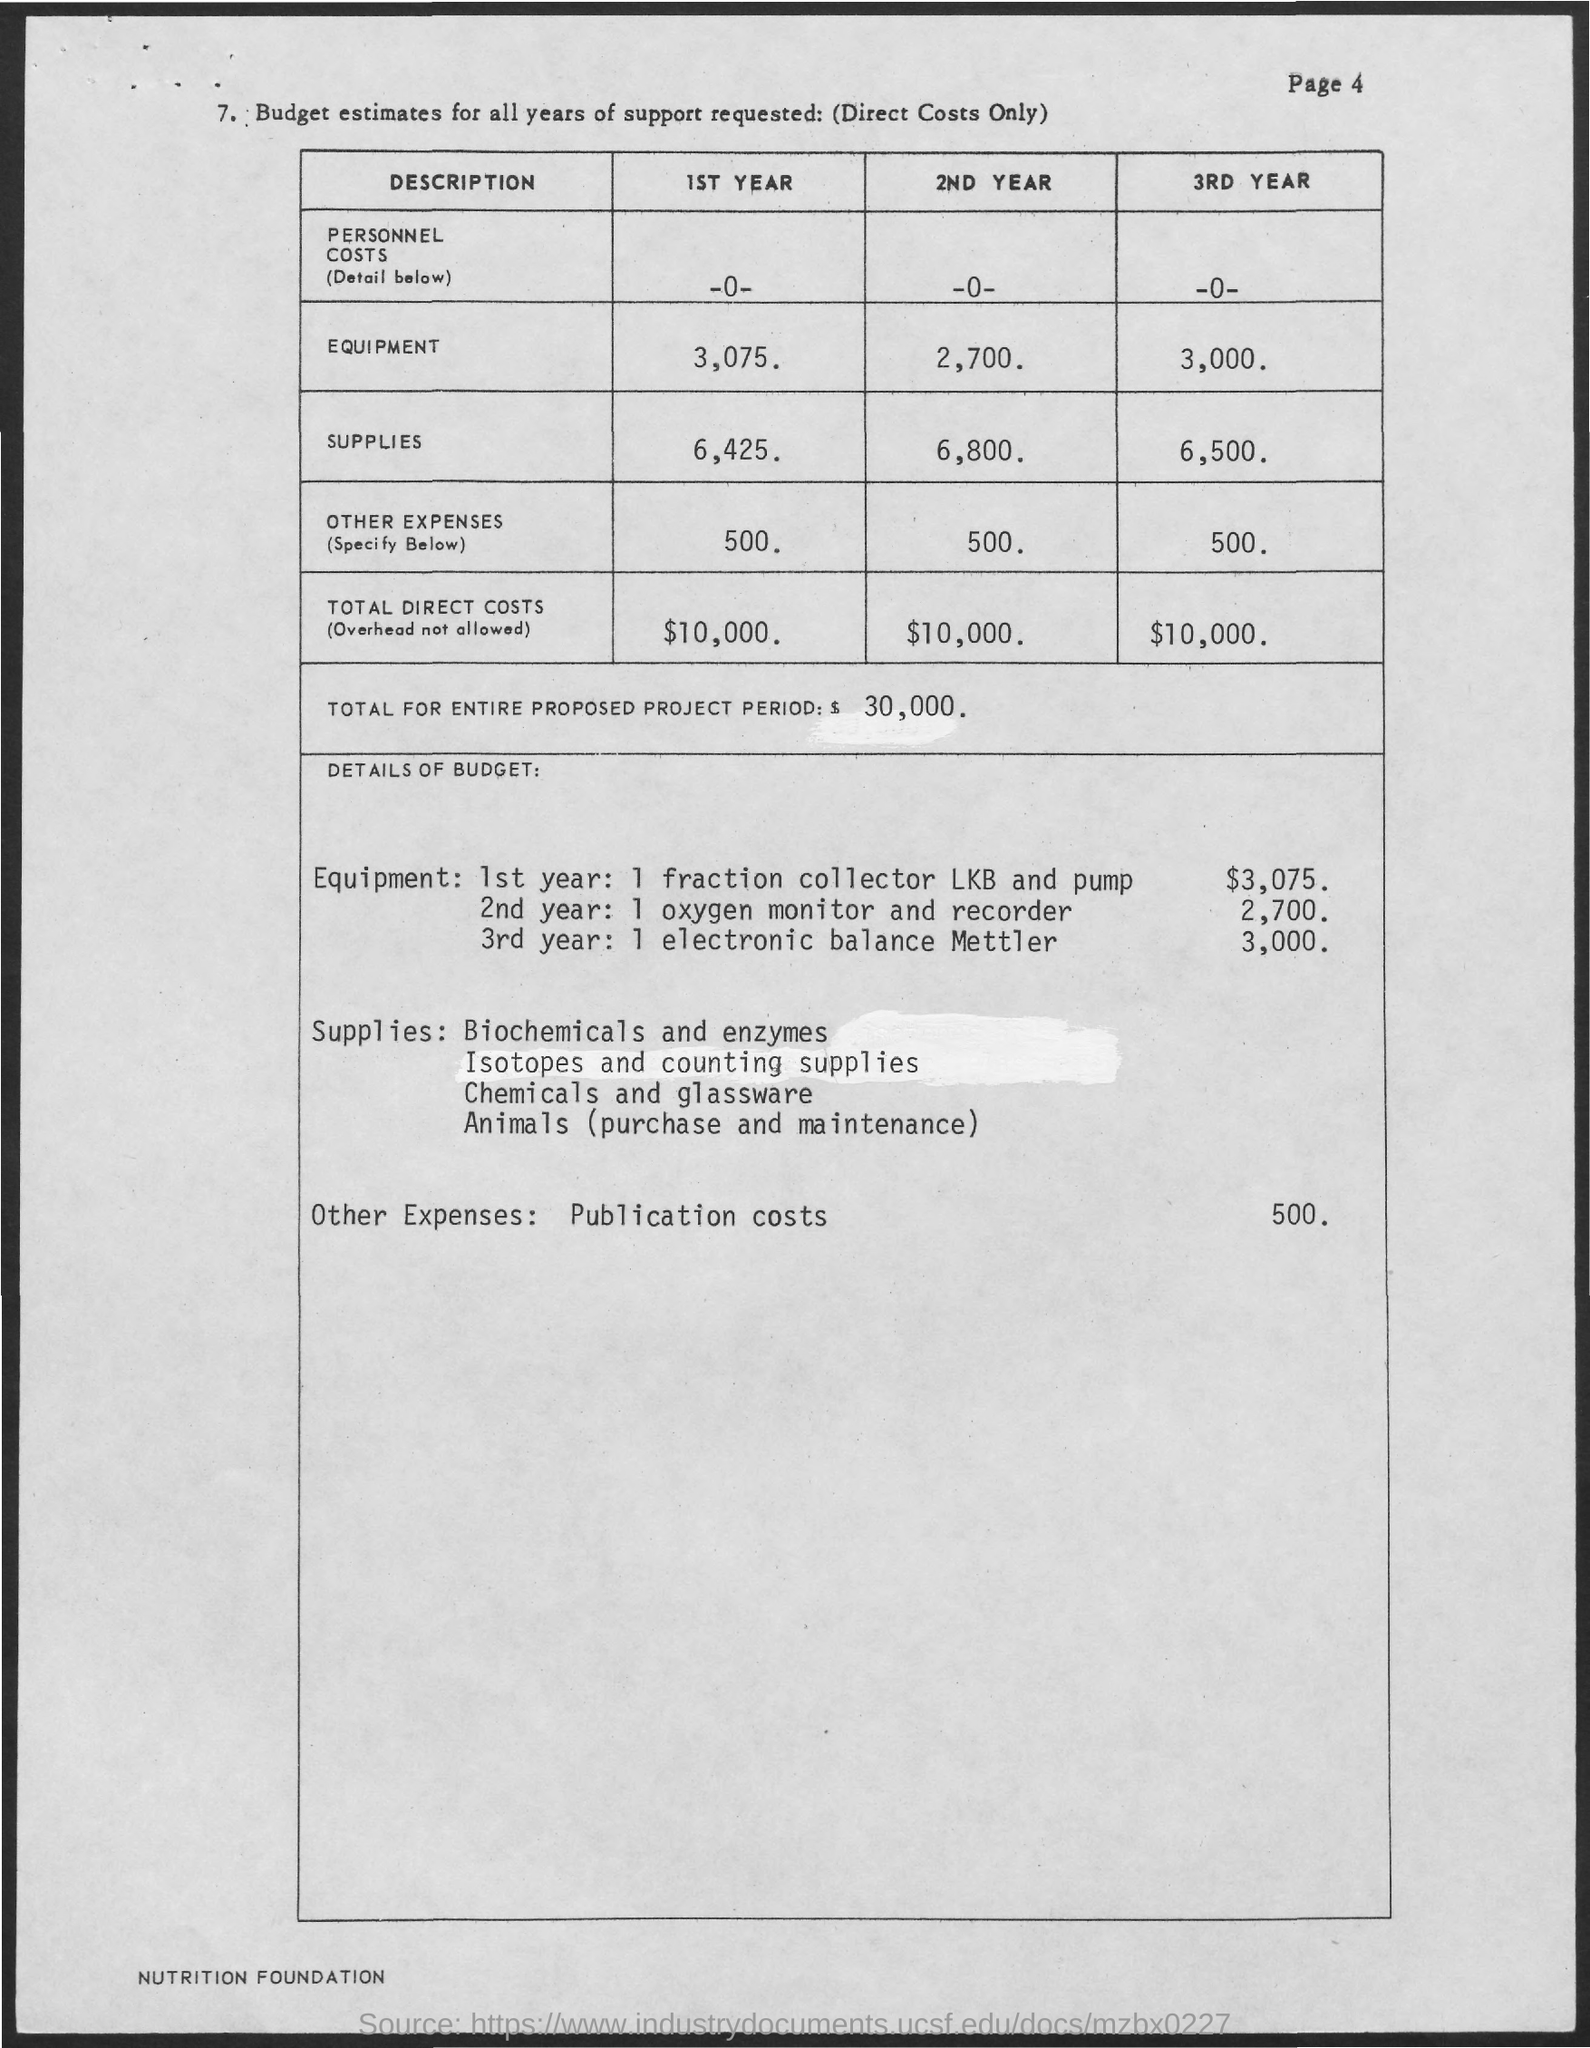What is the budget estimated for equipment in 1st year ?
Ensure brevity in your answer.  3,075. What is the estimated budget for supplies in 2nd year ?
Ensure brevity in your answer.  6,800. What is the estimated budget for supplies in 1st year ?
Offer a very short reply. 6,425. What is the total direct costs in 3rd year ?
Offer a very short reply. $10,000. What is the total direct costs in 1st year ?
Offer a terse response. $ 10,000. 